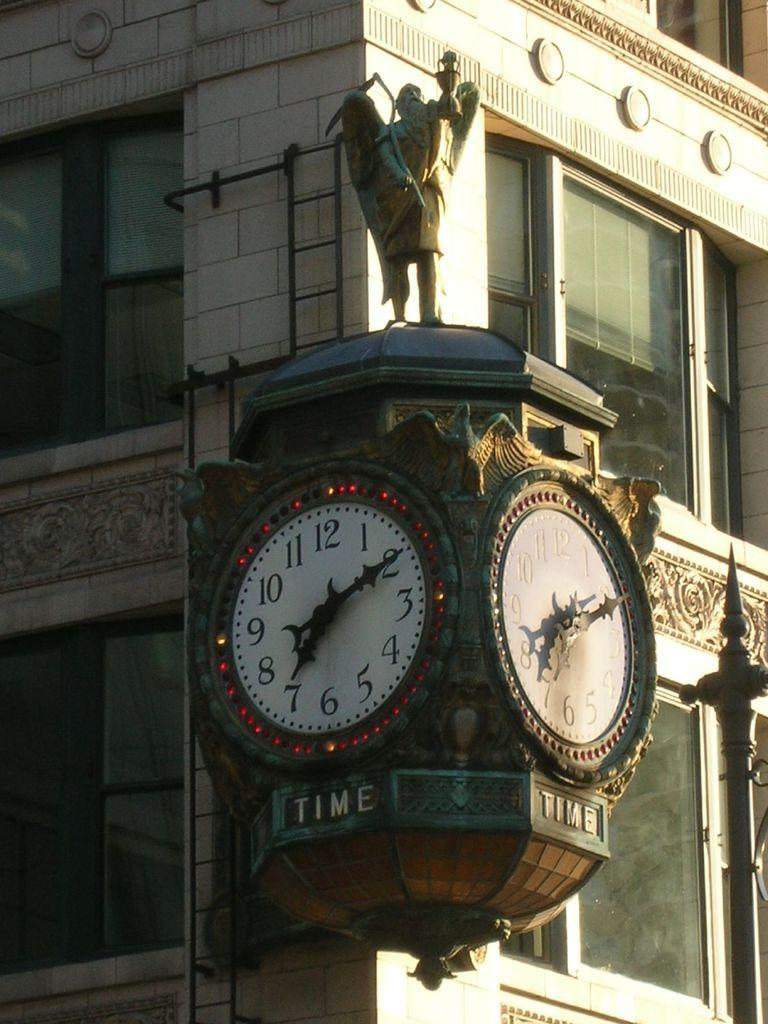What objects in the image are used for measuring time? There are clocks in the image that are used for measuring time. What type of structure can be seen in the image? There is a statue in the image. What architectural feature can be seen on the buildings in the background of the image? The buildings in the background of the image have mirrors. Can you describe the journey of the fairies in the image? There are no fairies present in the image, so it is not possible to describe their journey. What type of monkey can be seen climbing the statue in the image? There is no monkey present in the image; it features clocks, a statue, and buildings with mirrors. 